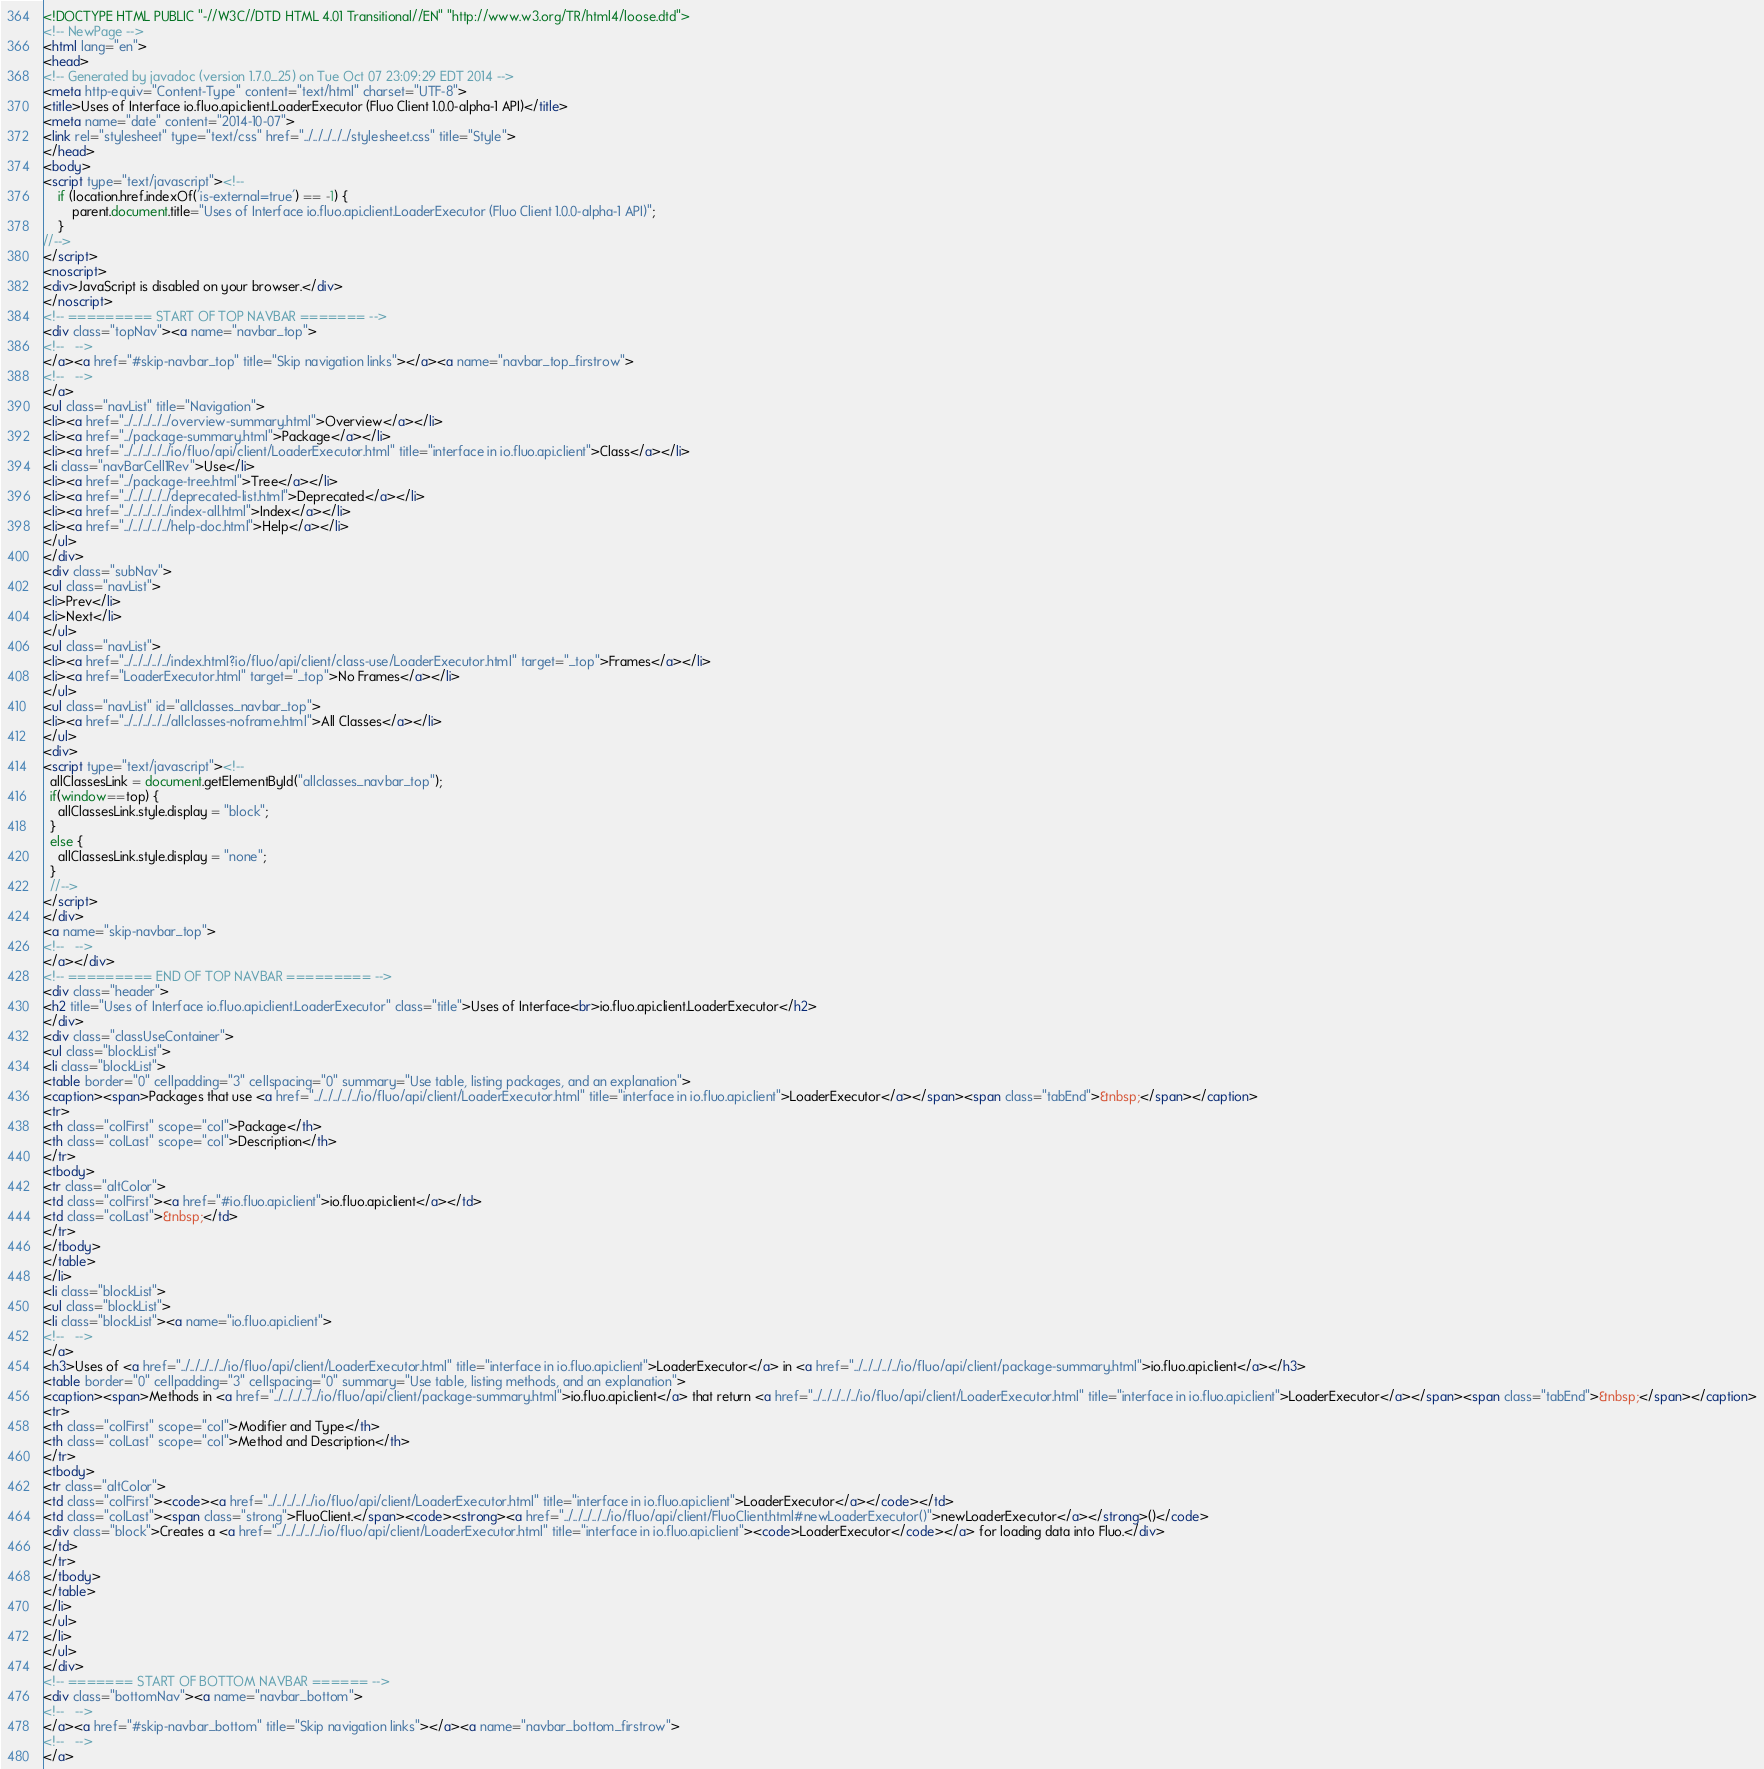Convert code to text. <code><loc_0><loc_0><loc_500><loc_500><_HTML_><!DOCTYPE HTML PUBLIC "-//W3C//DTD HTML 4.01 Transitional//EN" "http://www.w3.org/TR/html4/loose.dtd">
<!-- NewPage -->
<html lang="en">
<head>
<!-- Generated by javadoc (version 1.7.0_25) on Tue Oct 07 23:09:29 EDT 2014 -->
<meta http-equiv="Content-Type" content="text/html" charset="UTF-8">
<title>Uses of Interface io.fluo.api.client.LoaderExecutor (Fluo Client 1.0.0-alpha-1 API)</title>
<meta name="date" content="2014-10-07">
<link rel="stylesheet" type="text/css" href="../../../../../stylesheet.css" title="Style">
</head>
<body>
<script type="text/javascript"><!--
    if (location.href.indexOf('is-external=true') == -1) {
        parent.document.title="Uses of Interface io.fluo.api.client.LoaderExecutor (Fluo Client 1.0.0-alpha-1 API)";
    }
//-->
</script>
<noscript>
<div>JavaScript is disabled on your browser.</div>
</noscript>
<!-- ========= START OF TOP NAVBAR ======= -->
<div class="topNav"><a name="navbar_top">
<!--   -->
</a><a href="#skip-navbar_top" title="Skip navigation links"></a><a name="navbar_top_firstrow">
<!--   -->
</a>
<ul class="navList" title="Navigation">
<li><a href="../../../../../overview-summary.html">Overview</a></li>
<li><a href="../package-summary.html">Package</a></li>
<li><a href="../../../../../io/fluo/api/client/LoaderExecutor.html" title="interface in io.fluo.api.client">Class</a></li>
<li class="navBarCell1Rev">Use</li>
<li><a href="../package-tree.html">Tree</a></li>
<li><a href="../../../../../deprecated-list.html">Deprecated</a></li>
<li><a href="../../../../../index-all.html">Index</a></li>
<li><a href="../../../../../help-doc.html">Help</a></li>
</ul>
</div>
<div class="subNav">
<ul class="navList">
<li>Prev</li>
<li>Next</li>
</ul>
<ul class="navList">
<li><a href="../../../../../index.html?io/fluo/api/client/class-use/LoaderExecutor.html" target="_top">Frames</a></li>
<li><a href="LoaderExecutor.html" target="_top">No Frames</a></li>
</ul>
<ul class="navList" id="allclasses_navbar_top">
<li><a href="../../../../../allclasses-noframe.html">All Classes</a></li>
</ul>
<div>
<script type="text/javascript"><!--
  allClassesLink = document.getElementById("allclasses_navbar_top");
  if(window==top) {
    allClassesLink.style.display = "block";
  }
  else {
    allClassesLink.style.display = "none";
  }
  //-->
</script>
</div>
<a name="skip-navbar_top">
<!--   -->
</a></div>
<!-- ========= END OF TOP NAVBAR ========= -->
<div class="header">
<h2 title="Uses of Interface io.fluo.api.client.LoaderExecutor" class="title">Uses of Interface<br>io.fluo.api.client.LoaderExecutor</h2>
</div>
<div class="classUseContainer">
<ul class="blockList">
<li class="blockList">
<table border="0" cellpadding="3" cellspacing="0" summary="Use table, listing packages, and an explanation">
<caption><span>Packages that use <a href="../../../../../io/fluo/api/client/LoaderExecutor.html" title="interface in io.fluo.api.client">LoaderExecutor</a></span><span class="tabEnd">&nbsp;</span></caption>
<tr>
<th class="colFirst" scope="col">Package</th>
<th class="colLast" scope="col">Description</th>
</tr>
<tbody>
<tr class="altColor">
<td class="colFirst"><a href="#io.fluo.api.client">io.fluo.api.client</a></td>
<td class="colLast">&nbsp;</td>
</tr>
</tbody>
</table>
</li>
<li class="blockList">
<ul class="blockList">
<li class="blockList"><a name="io.fluo.api.client">
<!--   -->
</a>
<h3>Uses of <a href="../../../../../io/fluo/api/client/LoaderExecutor.html" title="interface in io.fluo.api.client">LoaderExecutor</a> in <a href="../../../../../io/fluo/api/client/package-summary.html">io.fluo.api.client</a></h3>
<table border="0" cellpadding="3" cellspacing="0" summary="Use table, listing methods, and an explanation">
<caption><span>Methods in <a href="../../../../../io/fluo/api/client/package-summary.html">io.fluo.api.client</a> that return <a href="../../../../../io/fluo/api/client/LoaderExecutor.html" title="interface in io.fluo.api.client">LoaderExecutor</a></span><span class="tabEnd">&nbsp;</span></caption>
<tr>
<th class="colFirst" scope="col">Modifier and Type</th>
<th class="colLast" scope="col">Method and Description</th>
</tr>
<tbody>
<tr class="altColor">
<td class="colFirst"><code><a href="../../../../../io/fluo/api/client/LoaderExecutor.html" title="interface in io.fluo.api.client">LoaderExecutor</a></code></td>
<td class="colLast"><span class="strong">FluoClient.</span><code><strong><a href="../../../../../io/fluo/api/client/FluoClient.html#newLoaderExecutor()">newLoaderExecutor</a></strong>()</code>
<div class="block">Creates a <a href="../../../../../io/fluo/api/client/LoaderExecutor.html" title="interface in io.fluo.api.client"><code>LoaderExecutor</code></a> for loading data into Fluo.</div>
</td>
</tr>
</tbody>
</table>
</li>
</ul>
</li>
</ul>
</div>
<!-- ======= START OF BOTTOM NAVBAR ====== -->
<div class="bottomNav"><a name="navbar_bottom">
<!--   -->
</a><a href="#skip-navbar_bottom" title="Skip navigation links"></a><a name="navbar_bottom_firstrow">
<!--   -->
</a></code> 